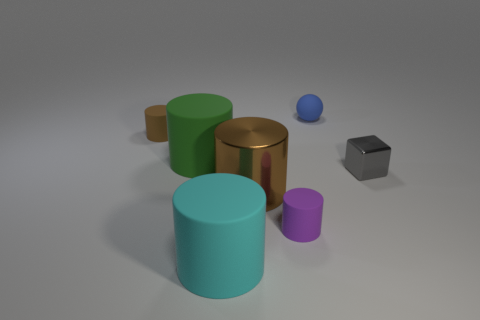The sphere that is made of the same material as the green cylinder is what color? The sphere which shares the same material characteristics as the green cylinder in the image, indicated by its similar matte finish and color tone nuances, is blue. 